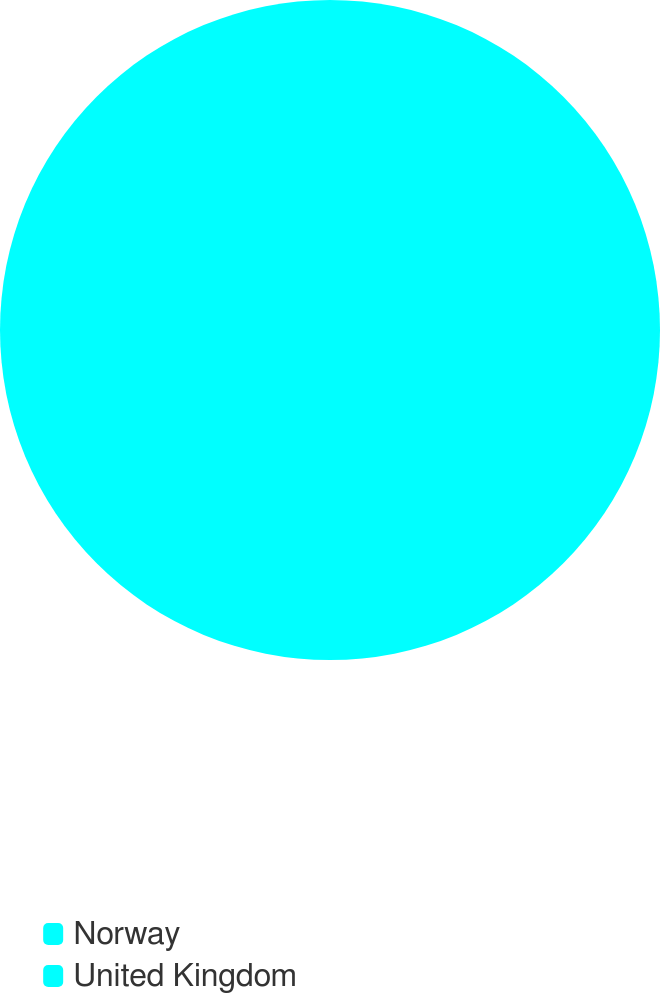<chart> <loc_0><loc_0><loc_500><loc_500><pie_chart><fcel>Norway<fcel>United Kingdom<nl><fcel>50.0%<fcel>50.0%<nl></chart> 